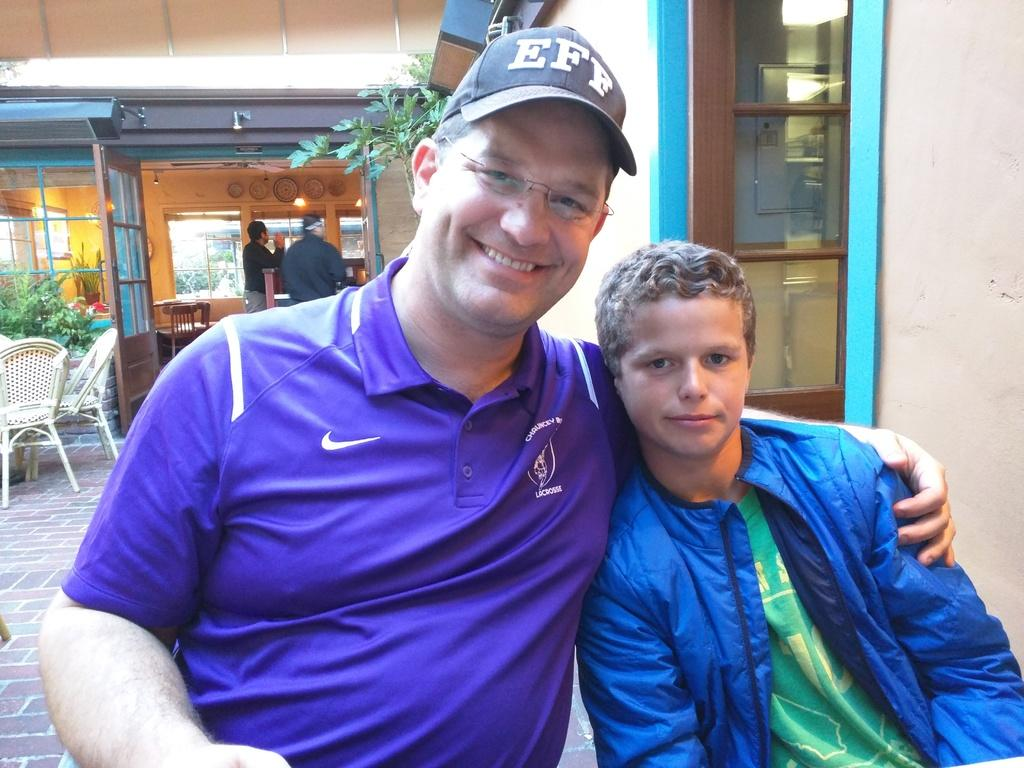How many people are in the image? There are people in the image. What else can be seen in the image besides people? There are plants, chairs, a building, doors, and lights in the image. Can you describe the person wearing glasses? A person is wearing glasses in the image. What is the person wearing on their head? A person is wearing a cap in the image. How is the person with glasses and a cap feeling? The person has a smile on their face, indicating they are happy or content. What type of coil is being used to support the sofa in the image? There is no sofa present in the image, so there is no coil to support it. What substance is being used to water the plants in the image? The image does not show any substance being used to water the plants; it only shows the plants themselves. 